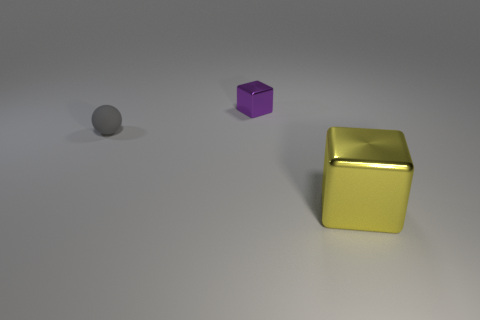Add 2 green balls. How many objects exist? 5 Subtract 0 brown spheres. How many objects are left? 3 Subtract all cubes. How many objects are left? 1 Subtract all small brown metallic cubes. Subtract all purple metallic cubes. How many objects are left? 2 Add 2 large cubes. How many large cubes are left? 3 Add 2 brown cylinders. How many brown cylinders exist? 2 